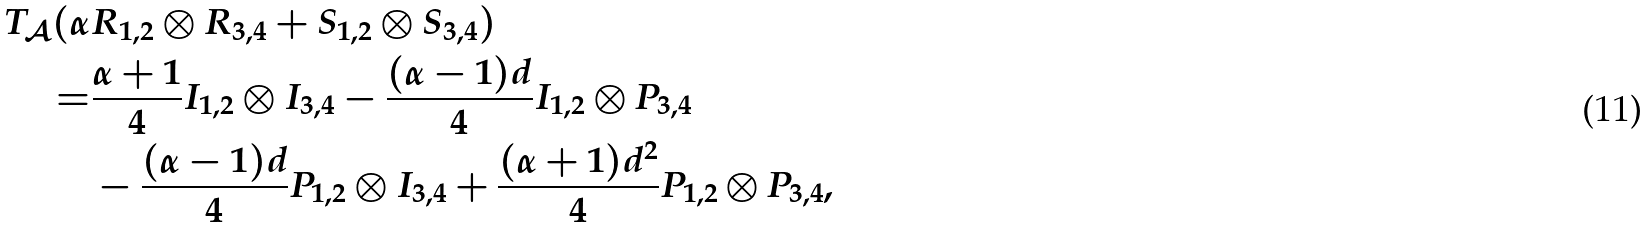Convert formula to latex. <formula><loc_0><loc_0><loc_500><loc_500>T _ { \mathcal { A } } ( \alpha & R _ { 1 , 2 } \otimes R _ { 3 , 4 } + S _ { 1 , 2 } \otimes S _ { 3 , 4 } ) \\ = & \frac { \alpha + 1 } { 4 } I _ { 1 , 2 } \otimes I _ { 3 , 4 } - \frac { ( \alpha - 1 ) d } { 4 } I _ { 1 , 2 } \otimes P _ { 3 , 4 } \\ & - \frac { ( \alpha - 1 ) d } { 4 } P _ { 1 , 2 } \otimes I _ { 3 , 4 } + \frac { ( \alpha + 1 ) d ^ { 2 } } { 4 } P _ { 1 , 2 } \otimes P _ { 3 , 4 } ,</formula> 